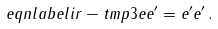<formula> <loc_0><loc_0><loc_500><loc_500>\ e q n l a b e l { i r - t m p 3 } e e ^ { \prime } = e ^ { \prime } e ^ { \prime } \, .</formula> 